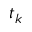Convert formula to latex. <formula><loc_0><loc_0><loc_500><loc_500>t _ { k }</formula> 